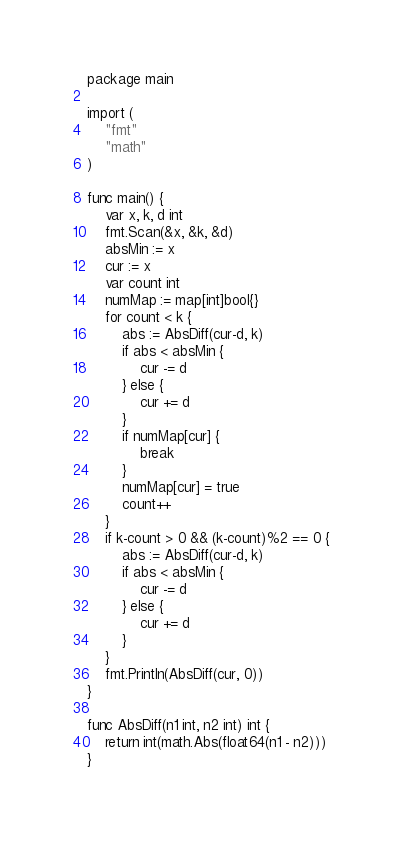Convert code to text. <code><loc_0><loc_0><loc_500><loc_500><_Go_>package main

import (
	"fmt"
	"math"
)

func main() {
	var x, k, d int
	fmt.Scan(&x, &k, &d)
	absMin := x
	cur := x
	var count int
	numMap := map[int]bool{}
	for count < k {
		abs := AbsDiff(cur-d, k)
		if abs < absMin {
			cur -= d
		} else {
			cur += d
		}
		if numMap[cur] {
			break
		}
		numMap[cur] = true
		count++
	}
	if k-count > 0 && (k-count)%2 == 0 {
		abs := AbsDiff(cur-d, k)
		if abs < absMin {
			cur -= d
		} else {
			cur += d
		}
	}
	fmt.Println(AbsDiff(cur, 0))
}

func AbsDiff(n1 int, n2 int) int {
	return int(math.Abs(float64(n1 - n2)))
}
</code> 